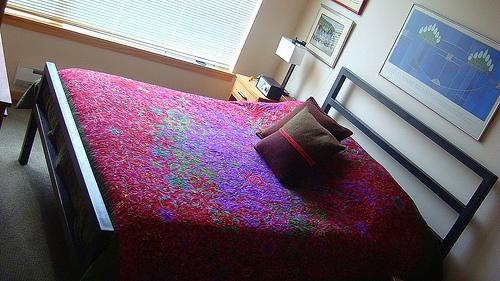Question: where are pillows?
Choices:
A. On a bed.
B. On a couch.
C. On a chair.
D. On a daybed.
Answer with the letter. Answer: A Question: what is red?
Choices:
A. Comforter.
B. Bedspread.
C. Blanket.
D. Quilt.
Answer with the letter. Answer: B Question: what is light brown?
Choices:
A. Side table.
B. Nightstand.
C. Table.
D. TV Stand.
Answer with the letter. Answer: A Question: how many pillows are on the bed?
Choices:
A. Three.
B. Four.
C. Five.
D. Two.
Answer with the letter. Answer: D Question: where are paintings?
Choices:
A. On the wall.
B. In the store.
C. At the mall.
D. On the floor.
Answer with the letter. Answer: A 